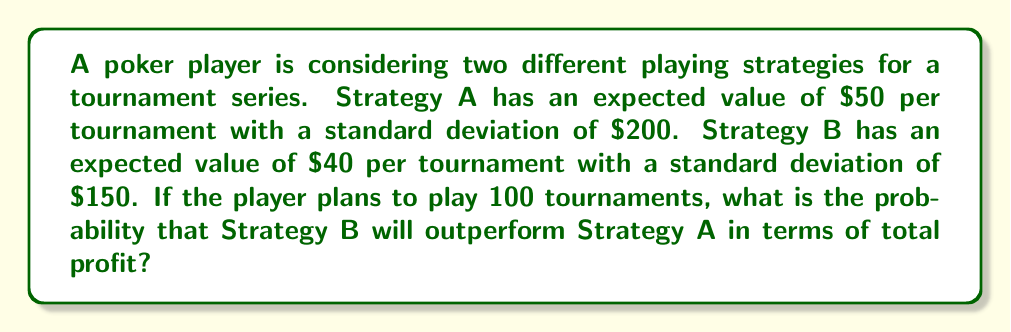Could you help me with this problem? To solve this problem, we'll use the Central Limit Theorem and the properties of normal distributions. Let's approach this step-by-step:

1) First, let's define our variables:
   $\mu_A = 50$, $\sigma_A = 200$ for Strategy A
   $\mu_B = 40$, $\sigma_B = 150$ for Strategy B
   $n = 100$ tournaments

2) For 100 tournaments, the expected total profit for each strategy is:
   Strategy A: $\mu_{A_{total}} = 100 \times 50 = 5000$
   Strategy B: $\mu_{B_{total}} = 100 \times 40 = 4000$

3) The standard deviation for the total profit over 100 tournaments is:
   Strategy A: $\sigma_{A_{total}} = 200 \times \sqrt{100} = 2000$
   Strategy B: $\sigma_{B_{total}} = 150 \times \sqrt{100} = 1500$

4) We want to find the probability that B outperforms A, which is equivalent to finding P(B - A > 0)

5) The difference (B - A) will also be normally distributed with:
   $\mu_{B-A} = \mu_B - \mu_A = 4000 - 5000 = -1000$
   $\sigma_{B-A} = \sqrt{\sigma_B^2 + \sigma_A^2} = \sqrt{1500^2 + 2000^2} = 2500$

6) We can standardize this to a Z-score:
   $Z = \frac{0 - (-1000)}{2500} = 0.4$

7) Using a standard normal distribution table or calculator, we can find the probability that Z > 0.4:
   P(Z > 0.4) ≈ 0.3446

Therefore, the probability that Strategy B will outperform Strategy A over 100 tournaments is approximately 0.3446 or 34.46%.
Answer: 0.3446 